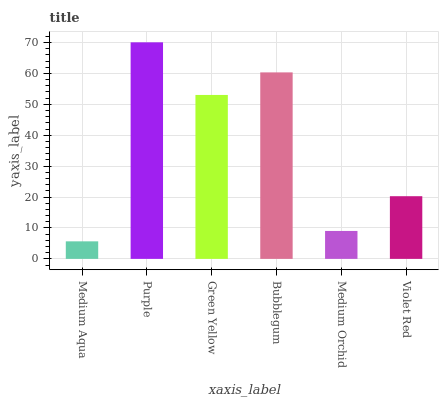Is Medium Aqua the minimum?
Answer yes or no. Yes. Is Purple the maximum?
Answer yes or no. Yes. Is Green Yellow the minimum?
Answer yes or no. No. Is Green Yellow the maximum?
Answer yes or no. No. Is Purple greater than Green Yellow?
Answer yes or no. Yes. Is Green Yellow less than Purple?
Answer yes or no. Yes. Is Green Yellow greater than Purple?
Answer yes or no. No. Is Purple less than Green Yellow?
Answer yes or no. No. Is Green Yellow the high median?
Answer yes or no. Yes. Is Violet Red the low median?
Answer yes or no. Yes. Is Bubblegum the high median?
Answer yes or no. No. Is Green Yellow the low median?
Answer yes or no. No. 